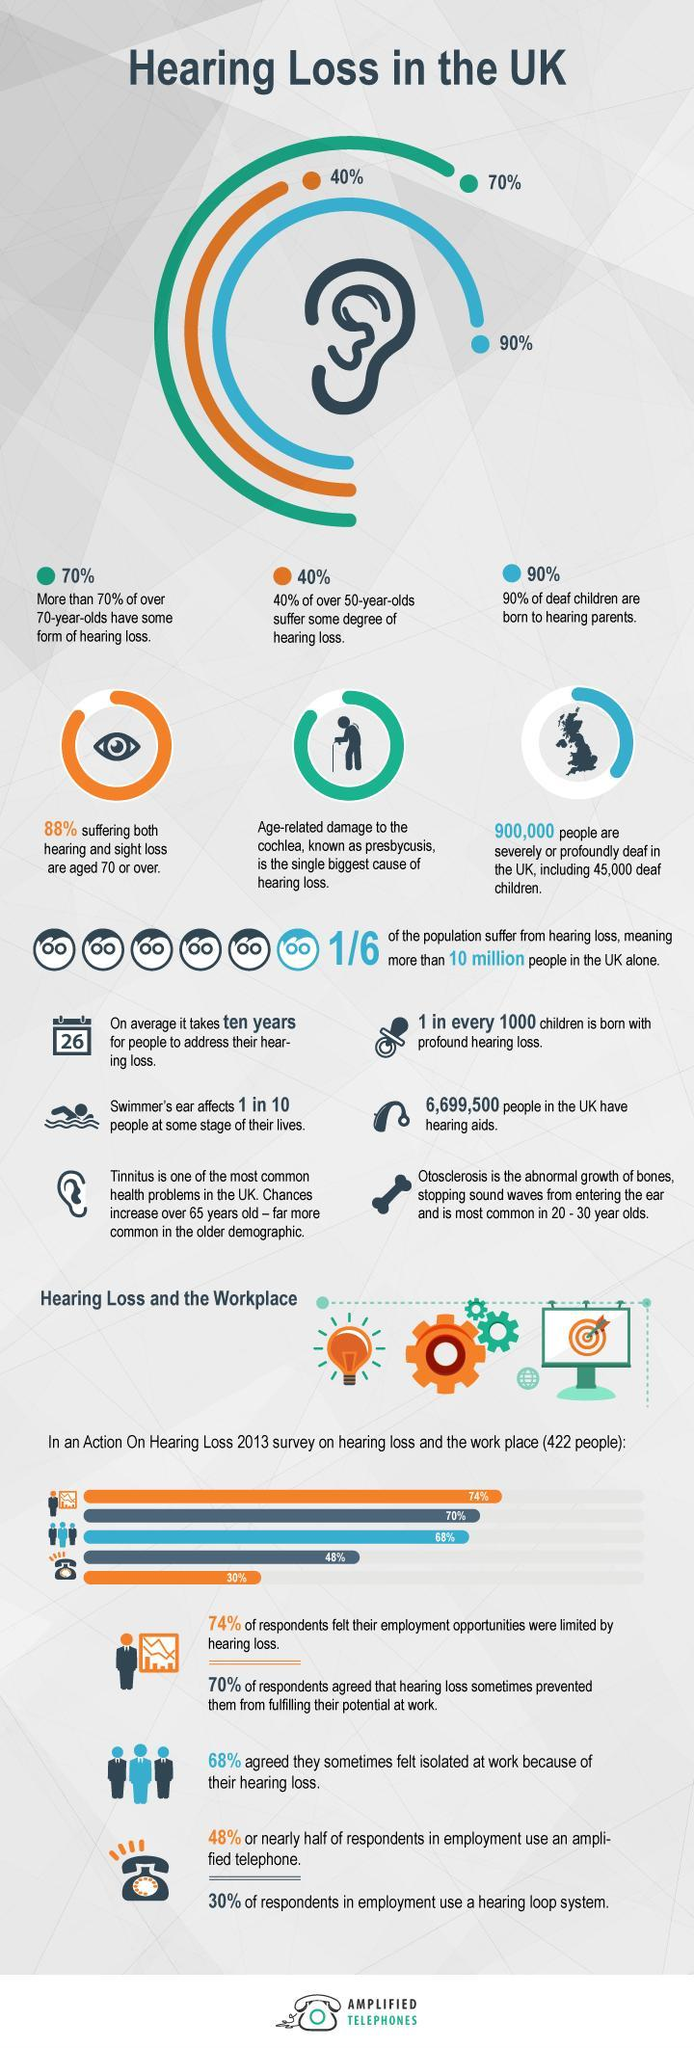What is the percentage of deaf children born to deaf parents?
Answer the question with a short phrase. 10% Malfunction of which part of ear is the main reason for hearing loss? Cochlea Name two ear problems that can affect elderly people. Presbycusis, Tinnitus Name a hearing problem that can especially affect the youth. Otosclerosis What is the percentage of children born with profound hearing loss? 0.10% 